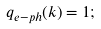<formula> <loc_0><loc_0><loc_500><loc_500>q _ { e - p h } ( k ) = 1 ;</formula> 